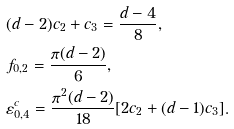Convert formula to latex. <formula><loc_0><loc_0><loc_500><loc_500>& ( d - 2 ) c _ { 2 } + c _ { 3 } = \frac { d - 4 } { 8 } , \\ & { f _ { 0 , 2 } } = \frac { \pi ( d - 2 ) } { 6 } , \\ & { \varepsilon ^ { c } _ { 0 , 4 } } = \frac { \pi ^ { 2 } ( d - 2 ) } { 1 8 } [ 2 c _ { 2 } + ( d - 1 ) c _ { 3 } ] .</formula> 